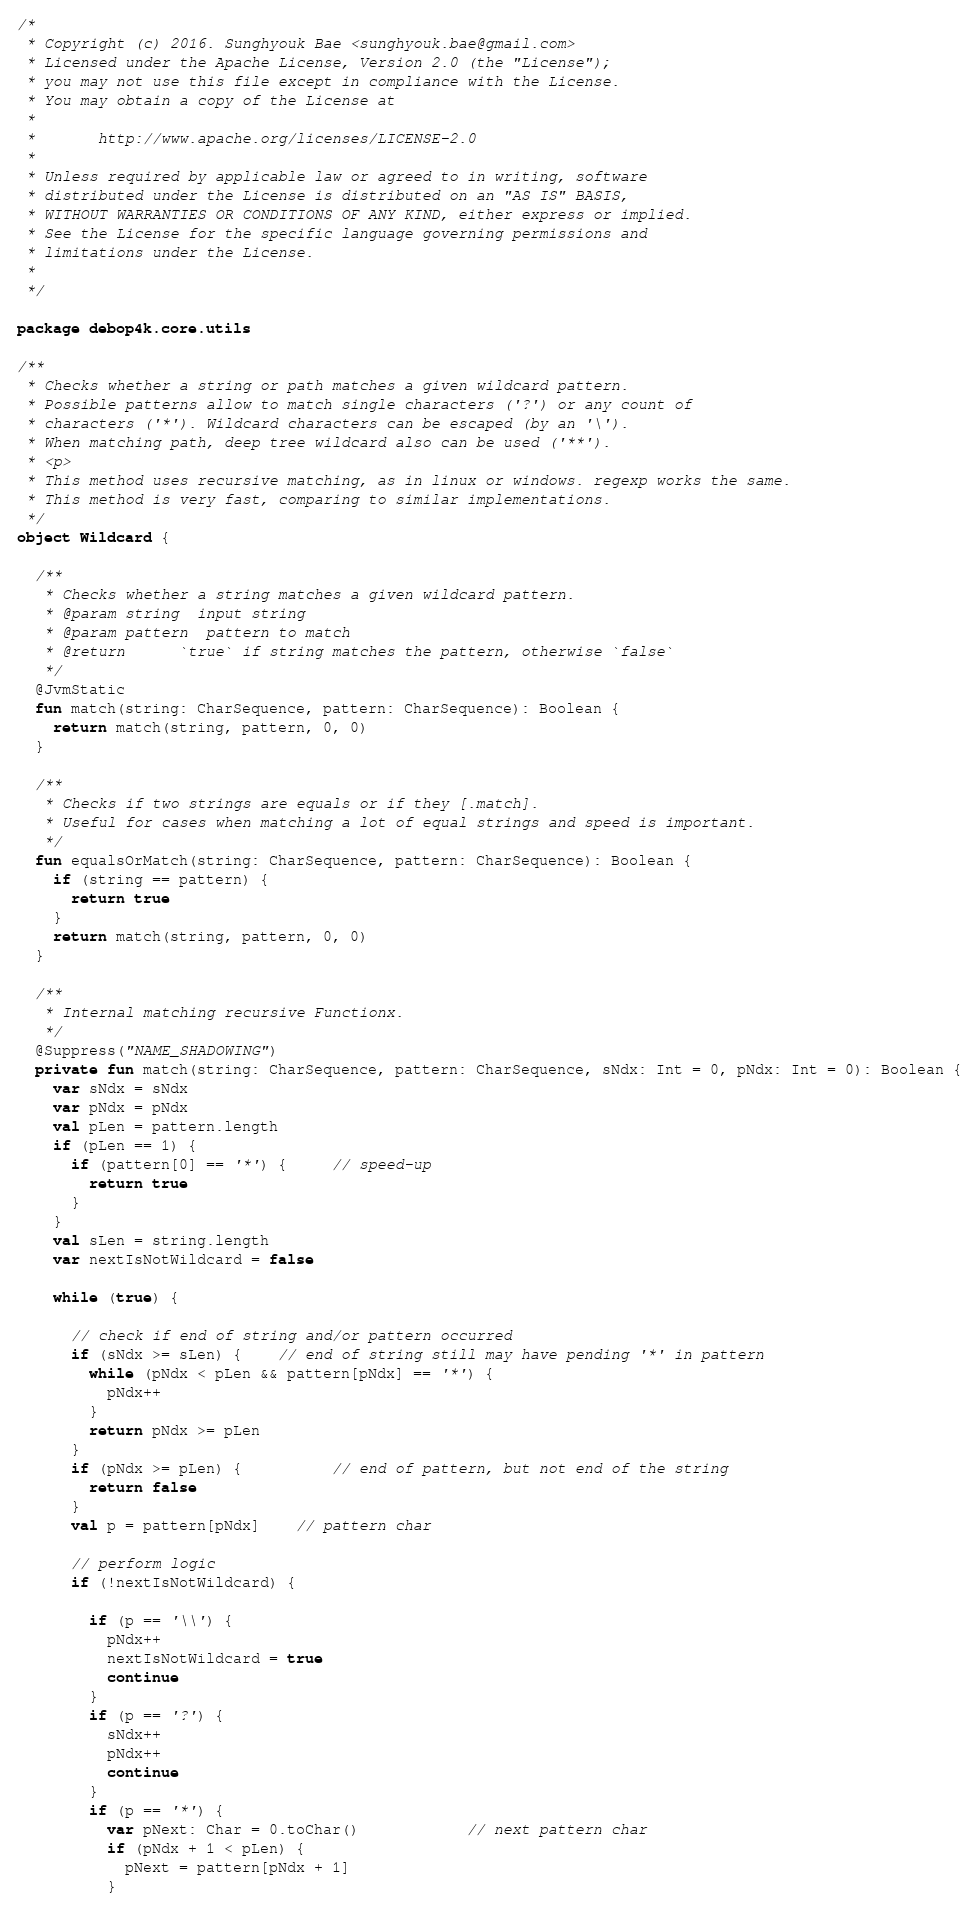Convert code to text. <code><loc_0><loc_0><loc_500><loc_500><_Kotlin_>/*
 * Copyright (c) 2016. Sunghyouk Bae <sunghyouk.bae@gmail.com>
 * Licensed under the Apache License, Version 2.0 (the "License");
 * you may not use this file except in compliance with the License.
 * You may obtain a copy of the License at
 *
 *       http://www.apache.org/licenses/LICENSE-2.0
 *
 * Unless required by applicable law or agreed to in writing, software
 * distributed under the License is distributed on an "AS IS" BASIS,
 * WITHOUT WARRANTIES OR CONDITIONS OF ANY KIND, either express or implied.
 * See the License for the specific language governing permissions and
 * limitations under the License.
 *
 */

package debop4k.core.utils

/**
 * Checks whether a string or path matches a given wildcard pattern.
 * Possible patterns allow to match single characters ('?') or any count of
 * characters ('*'). Wildcard characters can be escaped (by an '\').
 * When matching path, deep tree wildcard also can be used ('**').
 * <p>
 * This method uses recursive matching, as in linux or windows. regexp works the same.
 * This method is very fast, comparing to similar implementations.
 */
object Wildcard {

  /**
   * Checks whether a string matches a given wildcard pattern.
   * @param string  input string
   * @param pattern  pattern to match
   * @return      `true` if string matches the pattern, otherwise `false`
   */
  @JvmStatic
  fun match(string: CharSequence, pattern: CharSequence): Boolean {
    return match(string, pattern, 0, 0)
  }

  /**
   * Checks if two strings are equals or if they [.match].
   * Useful for cases when matching a lot of equal strings and speed is important.
   */
  fun equalsOrMatch(string: CharSequence, pattern: CharSequence): Boolean {
    if (string == pattern) {
      return true
    }
    return match(string, pattern, 0, 0)
  }

  /**
   * Internal matching recursive Functionx.
   */
  @Suppress("NAME_SHADOWING")
  private fun match(string: CharSequence, pattern: CharSequence, sNdx: Int = 0, pNdx: Int = 0): Boolean {
    var sNdx = sNdx
    var pNdx = pNdx
    val pLen = pattern.length
    if (pLen == 1) {
      if (pattern[0] == '*') {     // speed-up
        return true
      }
    }
    val sLen = string.length
    var nextIsNotWildcard = false

    while (true) {

      // check if end of string and/or pattern occurred
      if (sNdx >= sLen) {    // end of string still may have pending '*' in pattern
        while (pNdx < pLen && pattern[pNdx] == '*') {
          pNdx++
        }
        return pNdx >= pLen
      }
      if (pNdx >= pLen) {          // end of pattern, but not end of the string
        return false
      }
      val p = pattern[pNdx]    // pattern char

      // perform logic
      if (!nextIsNotWildcard) {

        if (p == '\\') {
          pNdx++
          nextIsNotWildcard = true
          continue
        }
        if (p == '?') {
          sNdx++
          pNdx++
          continue
        }
        if (p == '*') {
          var pNext: Char = 0.toChar()            // next pattern char
          if (pNdx + 1 < pLen) {
            pNext = pattern[pNdx + 1]
          }</code> 